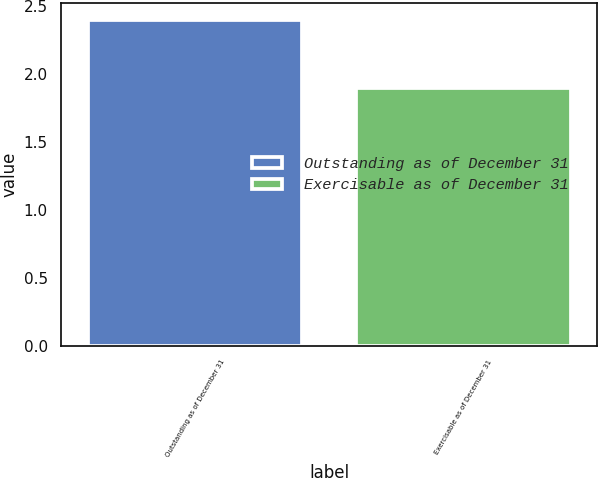Convert chart. <chart><loc_0><loc_0><loc_500><loc_500><bar_chart><fcel>Outstanding as of December 31<fcel>Exercisable as of December 31<nl><fcel>2.4<fcel>1.9<nl></chart> 